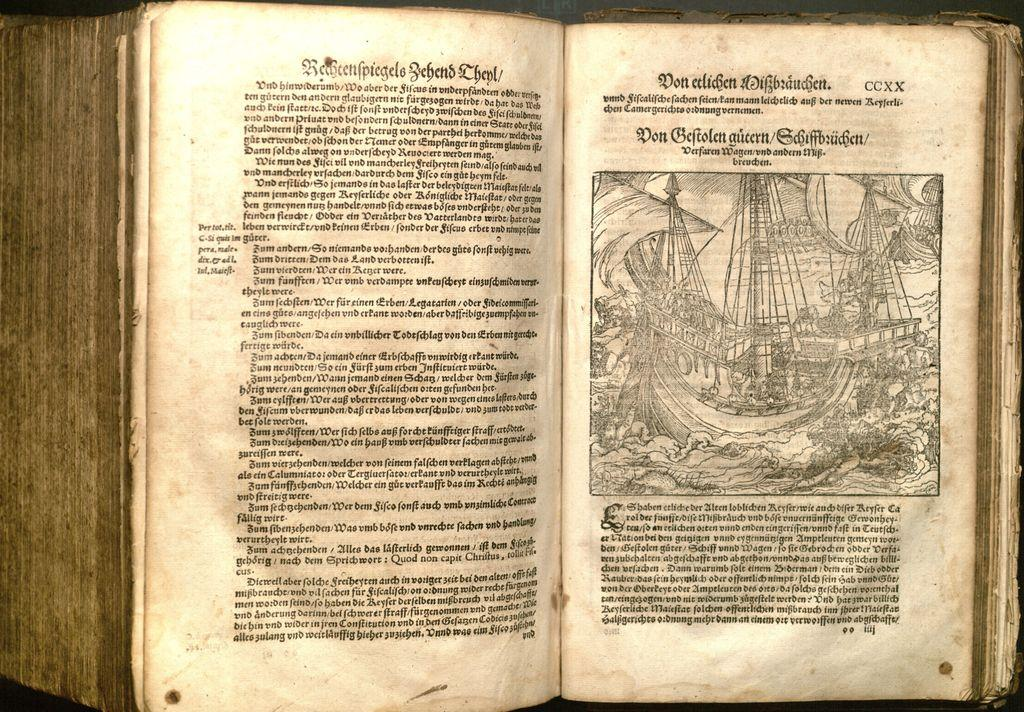Provide a one-sentence caption for the provided image. A book written in a foreign language, but the top right page displays a CCXX in the corner. 